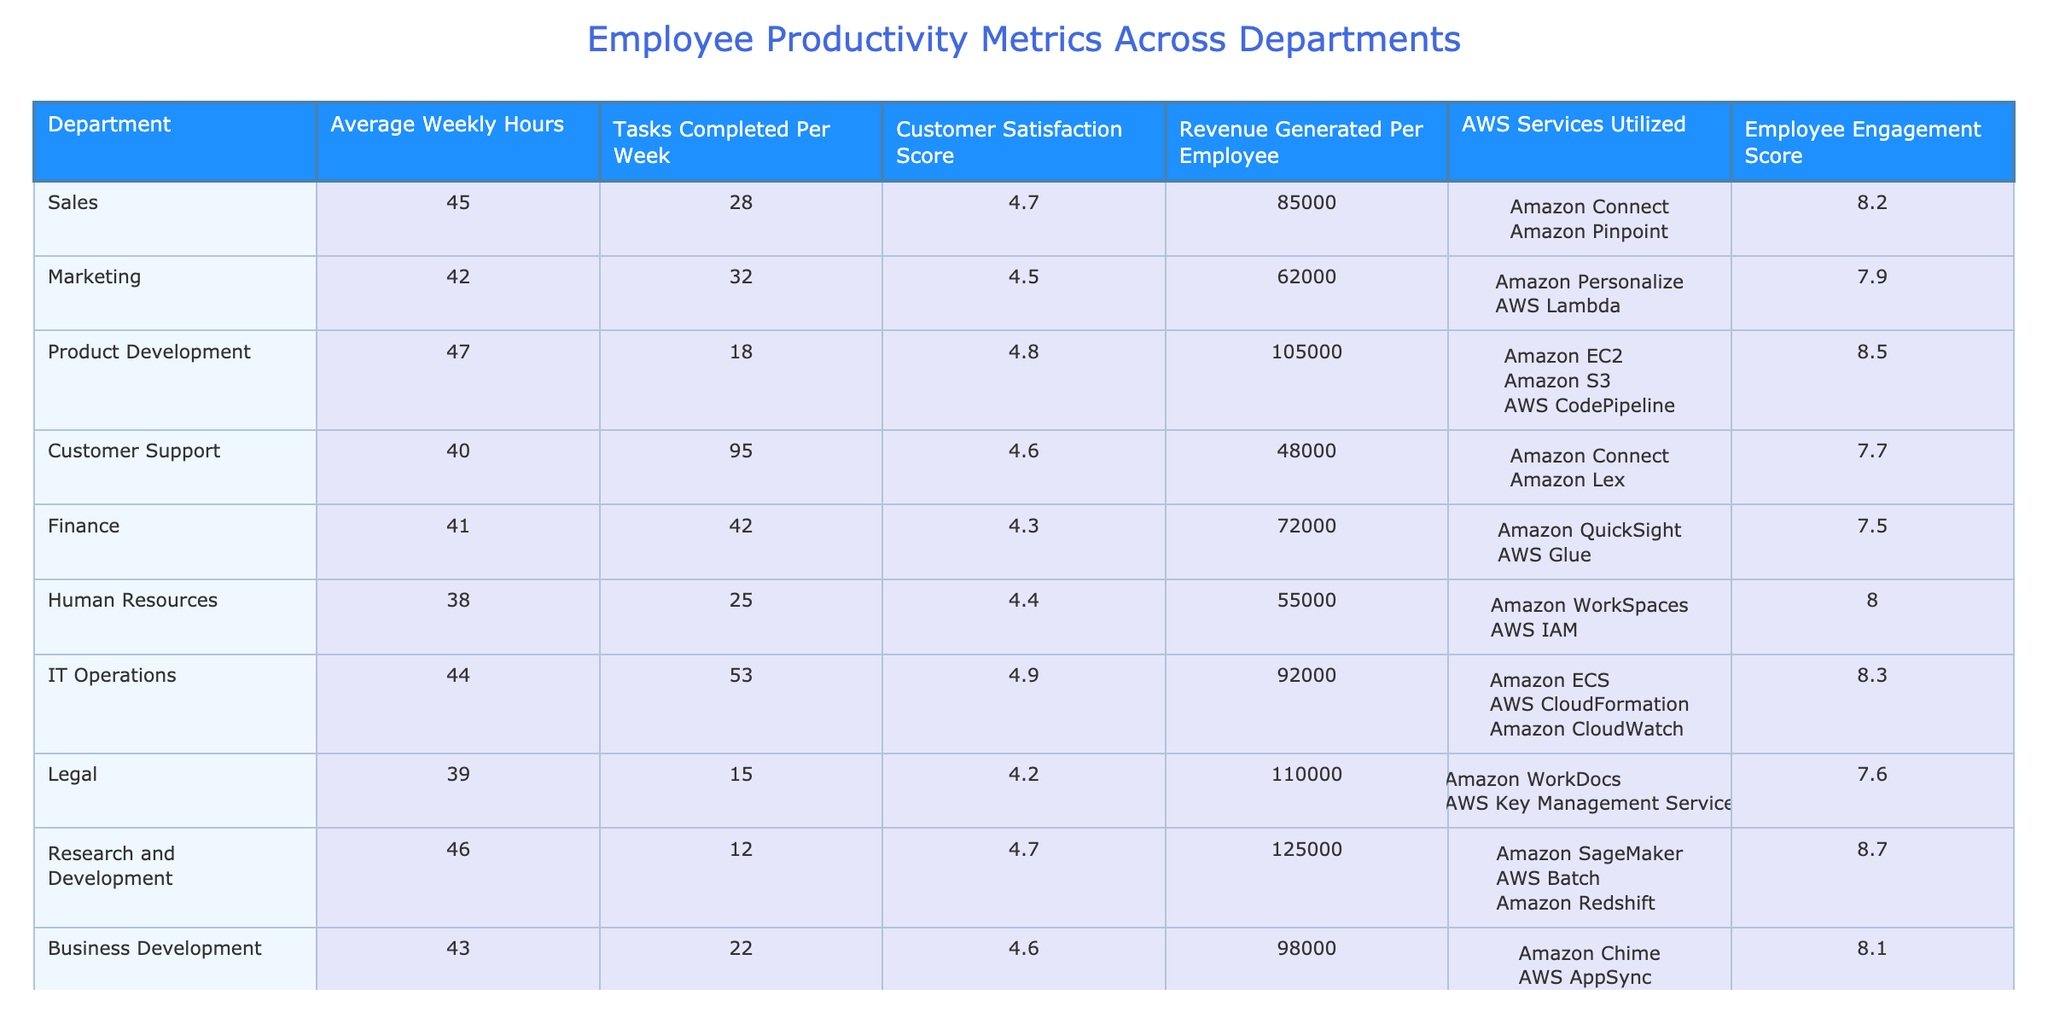What is the highest Customer Satisfaction Score among the departments? Looking at the table, the Customer Satisfaction Scores for each department are: Sales (4.7), Marketing (4.5), Product Development (4.8), Customer Support (4.6), Finance (4.3), Human Resources (4.4), IT Operations (4.9), Legal (4.2), Research and Development (4.7), and Business Development (4.6). The highest score is 4.9 for IT Operations.
Answer: 4.9 Which department generates the most revenue per employee? The Revenue Generated Per Employee for each department are: Sales (85000), Marketing (62000), Product Development (105000), Customer Support (48000), Finance (72000), Human Resources (55000), IT Operations (92000), Legal (110000), Research and Development (125000), and Business Development (98000). The maximum value is 125000 for Research and Development.
Answer: 125000 What is the average number of tasks completed per week across all departments? To find the average, sum the Tasks Completed Per Week: (28 + 32 + 18 + 95 + 42 + 25 + 53 + 15 + 12 + 22) = 362. Then divide by the number of departments (10): 362/10 = 36.2.
Answer: 36.2 Does the Marketing department achieve a higher Employee Engagement Score than the Finance department? The Employee Engagement Scores are Marketing (7.9) and Finance (7.5). Since 7.9 is greater than 7.5, Marketing does have a higher score.
Answer: Yes Which department has the lowest Average Weekly Hours, and what is that average? The Average Weekly Hours for each department are: Sales (45), Marketing (42), Product Development (47), Customer Support (40), Finance (41), Human Resources (38), IT Operations (44), Legal (39), Research and Development (46), and Business Development (43). The lowest value is 38 for Human Resources.
Answer: Human Resources, 38 What is the difference in Customer Satisfaction Score between the IT Operations and Customer Support departments? The Customer Satisfaction Score for IT Operations is 4.9, and for Customer Support, it is 4.6. The difference is 4.9 - 4.6 = 0.3.
Answer: 0.3 Which department has the highest Employee Engagement Score, and what AWS services do they utilize? The Employee Engagement Scores are: Sales (8.2), Marketing (7.9), Product Development (8.5), Customer Support (7.7), Finance (7.5), Human Resources (8.0), IT Operations (8.3), Legal (7.6), Research and Development (8.7), and Business Development (8.1). The highest score is 8.7 for Research and Development, which utilizes Amazon SageMaker, AWS Batch, and Amazon Redshift.
Answer: Research and Development, Amazon SageMaker;AWS Batch;Amazon Redshift Which department has both high tasks completed per week and a high Customer Satisfaction Score? Analyzing Tasks Completed Per Week and Customer Satisfaction Scores, Customer Support has 95 tasks and a satisfaction score of 4.6, while IT Operations has 53 tasks and a score of 4.9. Since 95 and 4.6 are higher compared to others, Customer Support meets the criteria.
Answer: Customer Support Is there a department that has an average weekly hour count higher than 45 but completed fewer than 20 tasks per week? The departments with hours higher than 45 are Product Development (47 hours, 18 tasks) and Research and Development (46 hours, 12 tasks). Both of these departments completed fewer than 20 tasks.
Answer: Yes, Product Development and Research and Development 